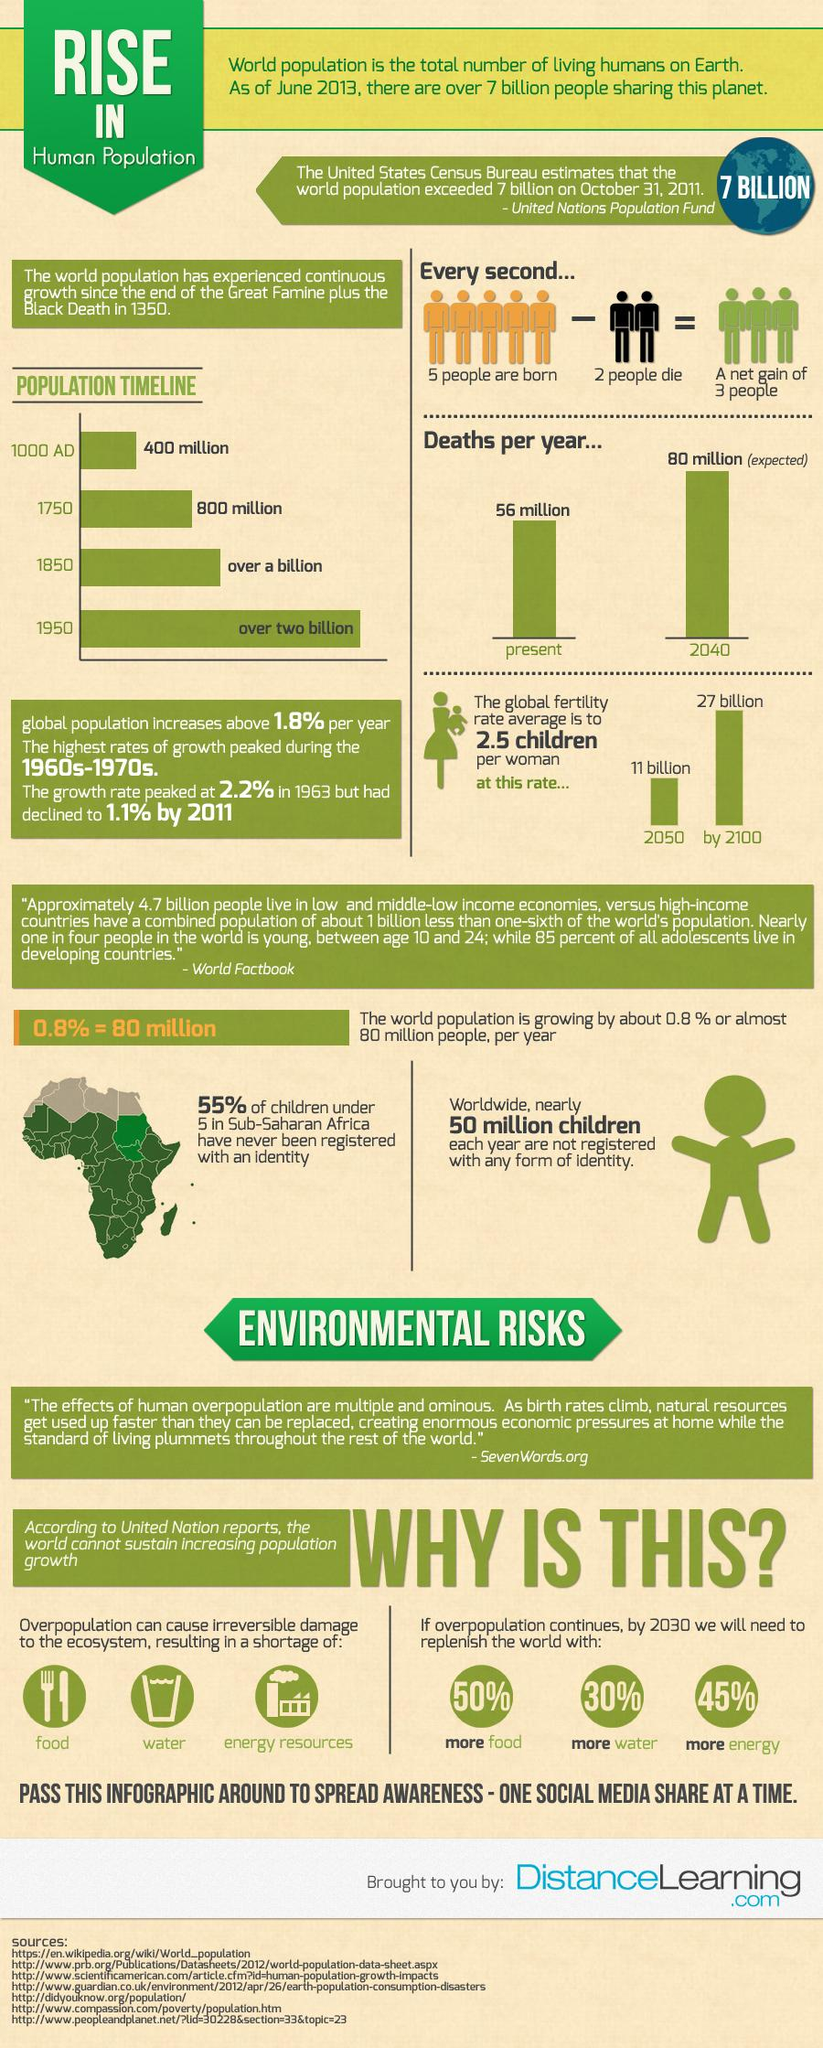Indicate a few pertinent items in this graphic. It is estimated that two human beings are losing their lives every second. If humans are to survive by 2030, a significant amount of food will be required. Specifically, 50% of the current food production levels will be necessary to ensure the survival of the global population. Overpopulation has a significant impact on the availability of food, water, and energy resources, which are essential for the well-being of society. It is projected that by the year 2100, the number of people on Earth will be approximately 27 billion. Overpopulation has a significant impact on the environment, and it is the third element of the ecosystem that is affected. Specifically, energy resources are significantly reduced due to overpopulation. 